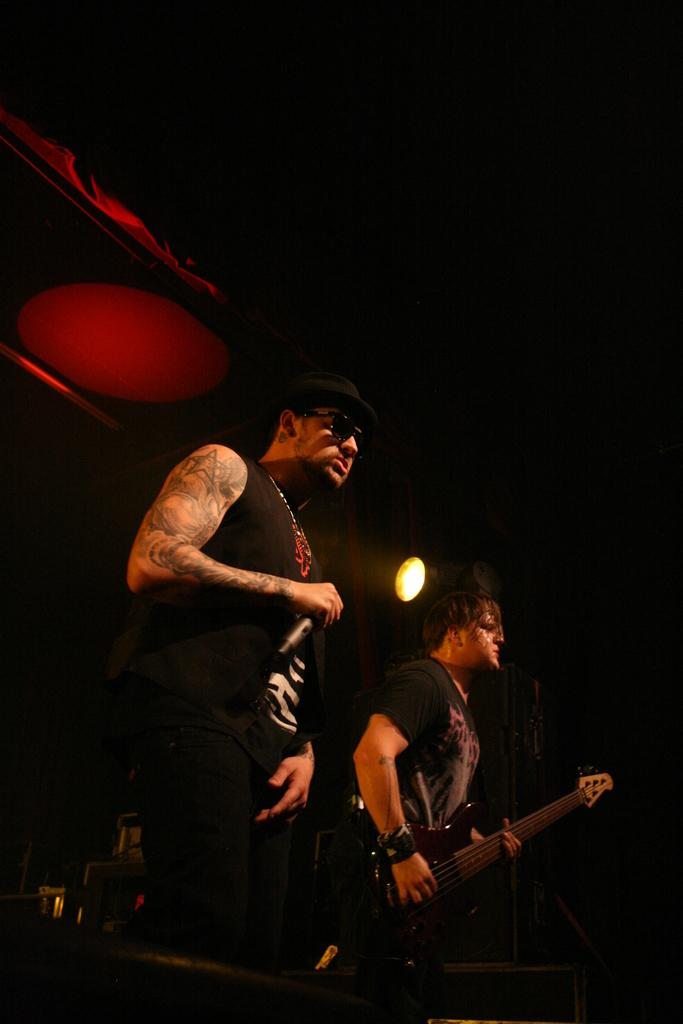How many people are in the image? There are two persons in the image. What are the people wearing? Both persons are wearing black costumes. What is one person holding in the image? One person is holding a microphone. What is the other person holding in the image? The other person is holding a guitar. What type of branch can be seen in the image? There is no branch present in the image. What type of legal advice is the person with the microphone providing in the image? There is no indication of legal advice or a lawyer in the image; it features two people, one holding a microphone and the other holding a guitar. 